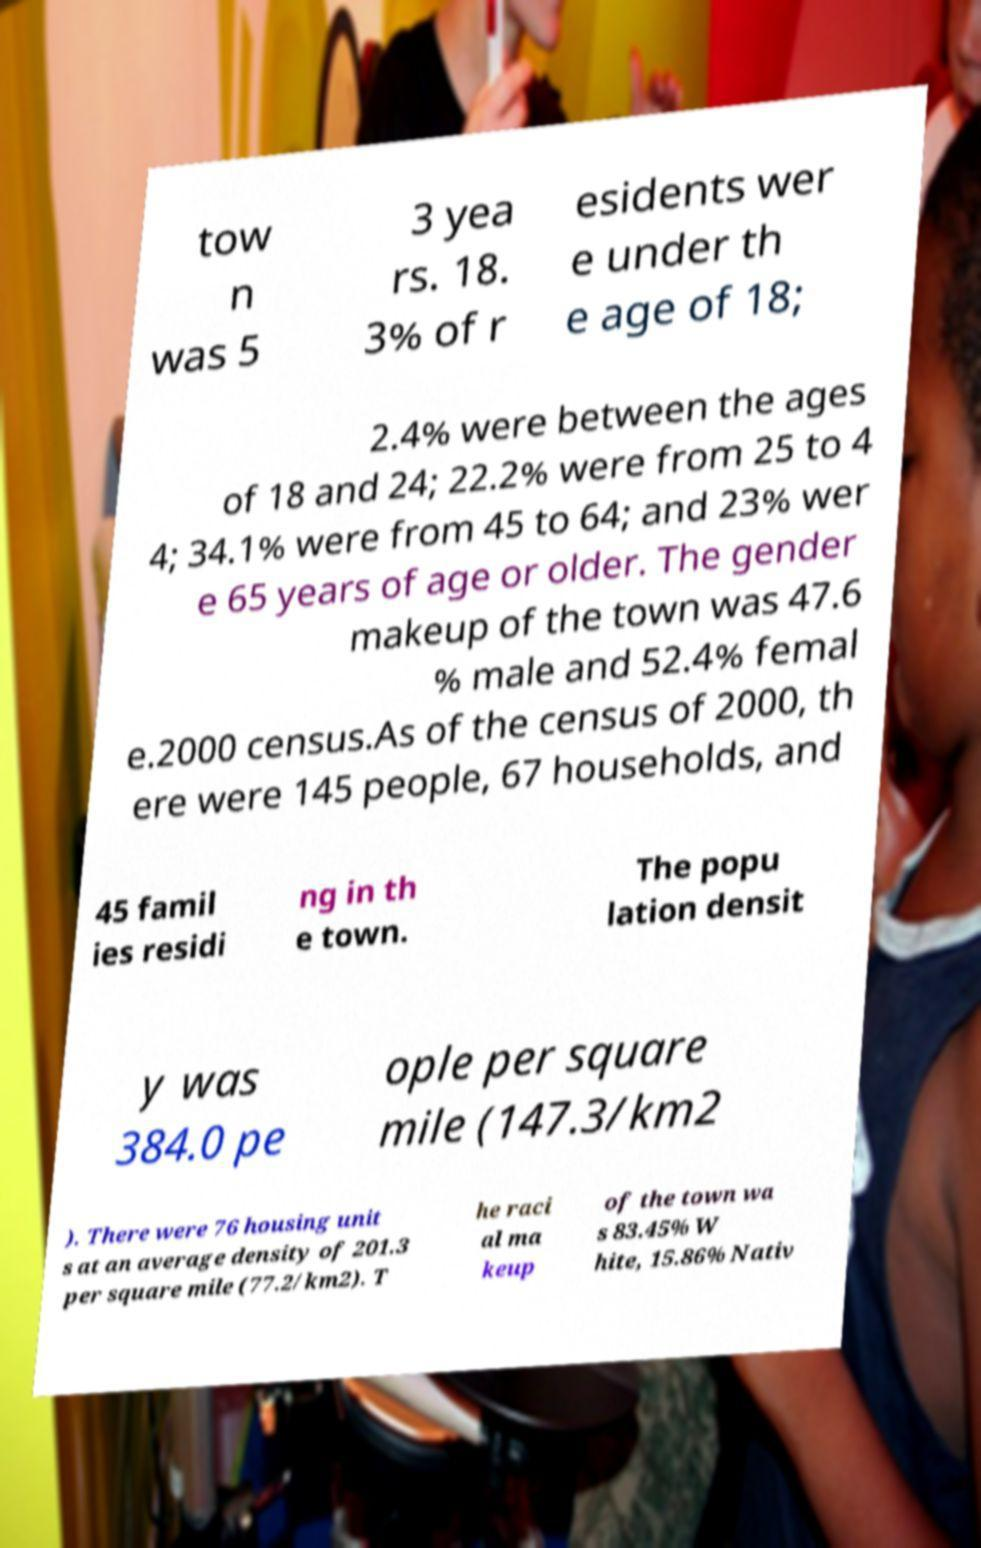Please identify and transcribe the text found in this image. tow n was 5 3 yea rs. 18. 3% of r esidents wer e under th e age of 18; 2.4% were between the ages of 18 and 24; 22.2% were from 25 to 4 4; 34.1% were from 45 to 64; and 23% wer e 65 years of age or older. The gender makeup of the town was 47.6 % male and 52.4% femal e.2000 census.As of the census of 2000, th ere were 145 people, 67 households, and 45 famil ies residi ng in th e town. The popu lation densit y was 384.0 pe ople per square mile (147.3/km2 ). There were 76 housing unit s at an average density of 201.3 per square mile (77.2/km2). T he raci al ma keup of the town wa s 83.45% W hite, 15.86% Nativ 